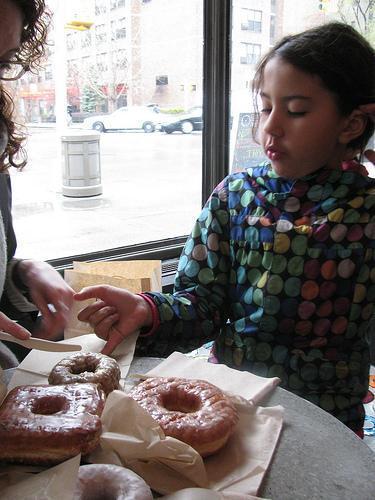How many doughnuts are there?
Give a very brief answer. 4. How many square donuts are in the picture?
Give a very brief answer. 1. 